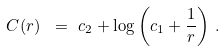Convert formula to latex. <formula><loc_0><loc_0><loc_500><loc_500>C ( r ) \ & = \ c _ { 2 } + \log \left ( c _ { 1 } + \frac { 1 } { r } \right ) \, .</formula> 